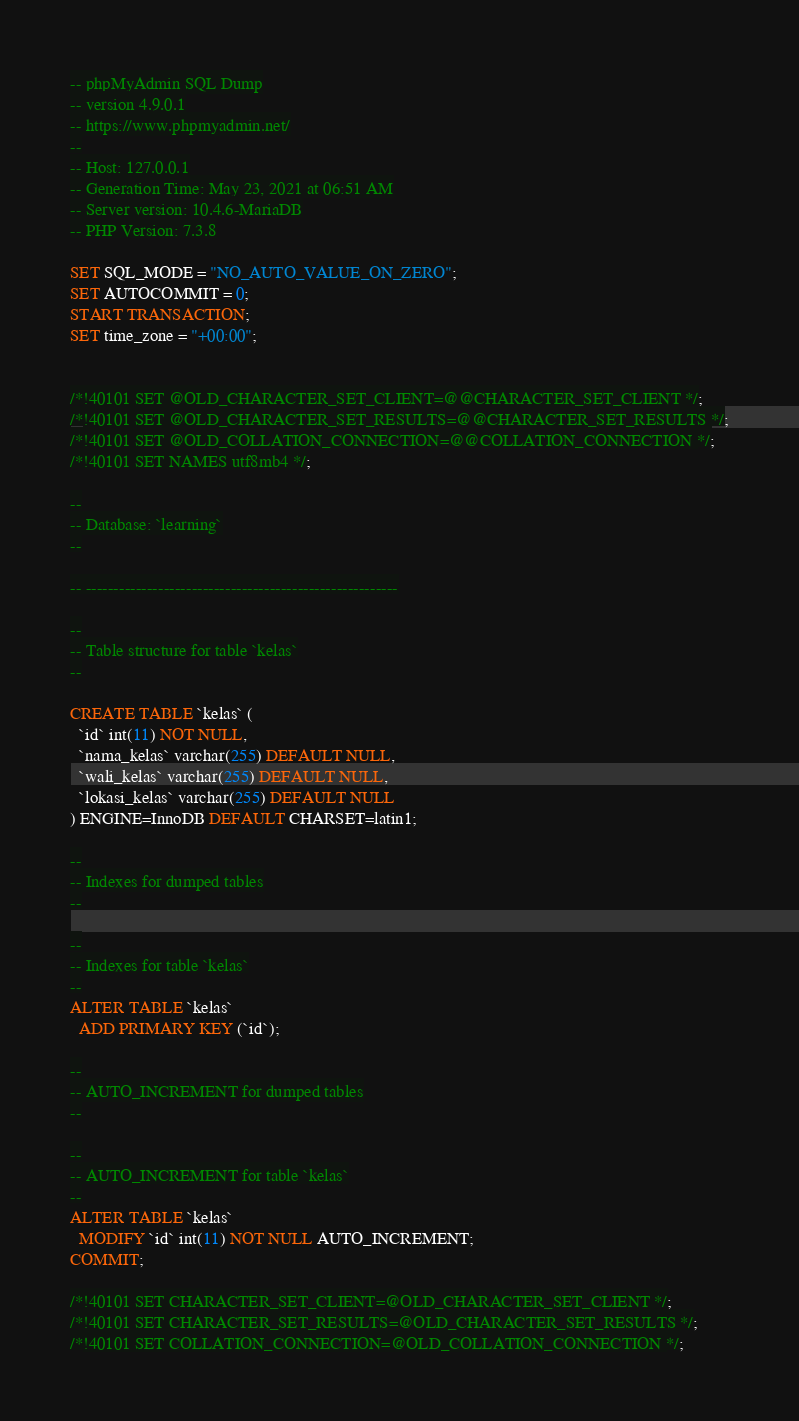Convert code to text. <code><loc_0><loc_0><loc_500><loc_500><_SQL_>-- phpMyAdmin SQL Dump
-- version 4.9.0.1
-- https://www.phpmyadmin.net/
--
-- Host: 127.0.0.1
-- Generation Time: May 23, 2021 at 06:51 AM
-- Server version: 10.4.6-MariaDB
-- PHP Version: 7.3.8

SET SQL_MODE = "NO_AUTO_VALUE_ON_ZERO";
SET AUTOCOMMIT = 0;
START TRANSACTION;
SET time_zone = "+00:00";


/*!40101 SET @OLD_CHARACTER_SET_CLIENT=@@CHARACTER_SET_CLIENT */;
/*!40101 SET @OLD_CHARACTER_SET_RESULTS=@@CHARACTER_SET_RESULTS */;
/*!40101 SET @OLD_COLLATION_CONNECTION=@@COLLATION_CONNECTION */;
/*!40101 SET NAMES utf8mb4 */;

--
-- Database: `learning`
--

-- --------------------------------------------------------

--
-- Table structure for table `kelas`
--

CREATE TABLE `kelas` (
  `id` int(11) NOT NULL,
  `nama_kelas` varchar(255) DEFAULT NULL,
  `wali_kelas` varchar(255) DEFAULT NULL,
  `lokasi_kelas` varchar(255) DEFAULT NULL
) ENGINE=InnoDB DEFAULT CHARSET=latin1;

--
-- Indexes for dumped tables
--

--
-- Indexes for table `kelas`
--
ALTER TABLE `kelas`
  ADD PRIMARY KEY (`id`);

--
-- AUTO_INCREMENT for dumped tables
--

--
-- AUTO_INCREMENT for table `kelas`
--
ALTER TABLE `kelas`
  MODIFY `id` int(11) NOT NULL AUTO_INCREMENT;
COMMIT;

/*!40101 SET CHARACTER_SET_CLIENT=@OLD_CHARACTER_SET_CLIENT */;
/*!40101 SET CHARACTER_SET_RESULTS=@OLD_CHARACTER_SET_RESULTS */;
/*!40101 SET COLLATION_CONNECTION=@OLD_COLLATION_CONNECTION */;
</code> 